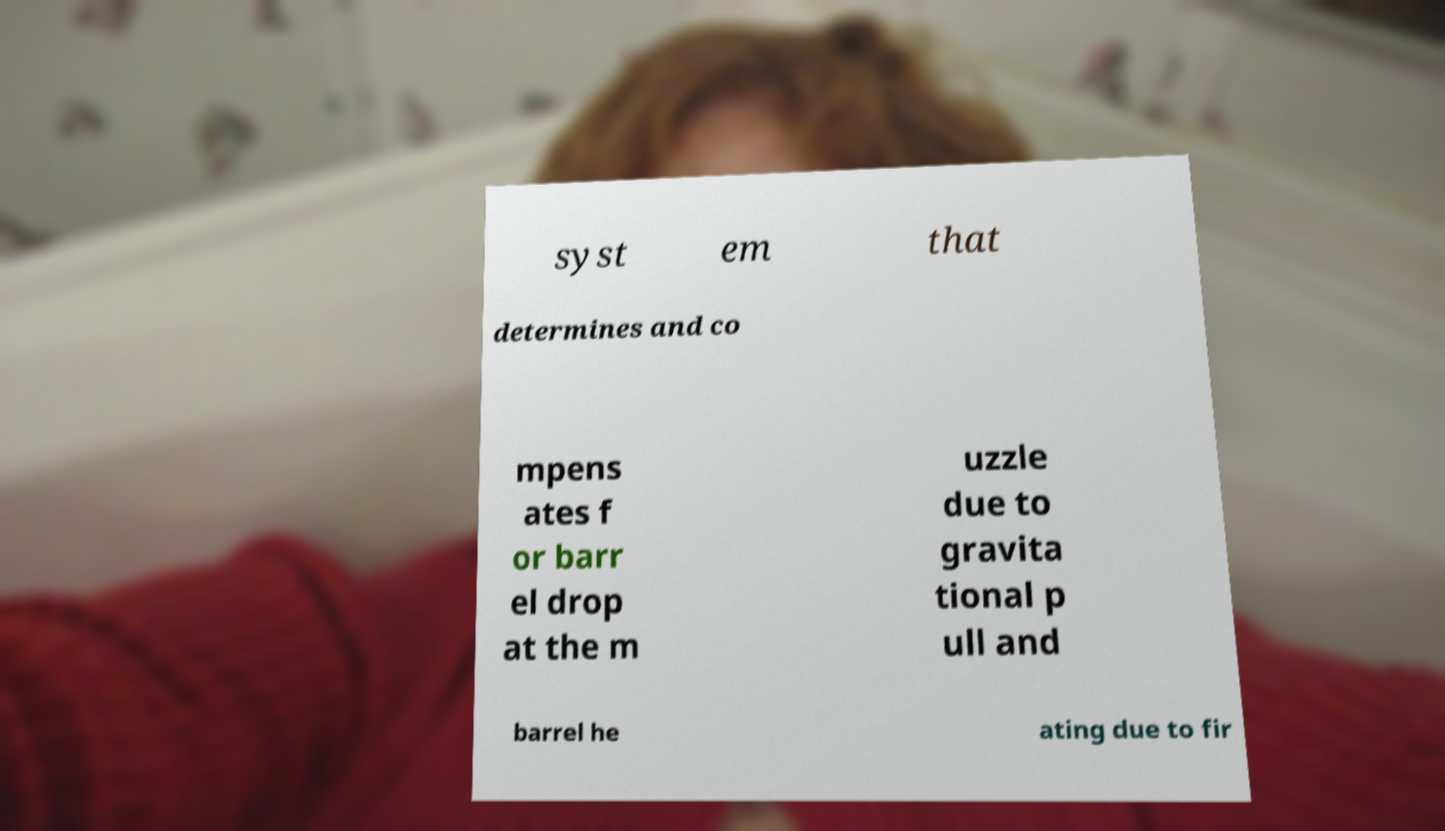There's text embedded in this image that I need extracted. Can you transcribe it verbatim? syst em that determines and co mpens ates f or barr el drop at the m uzzle due to gravita tional p ull and barrel he ating due to fir 